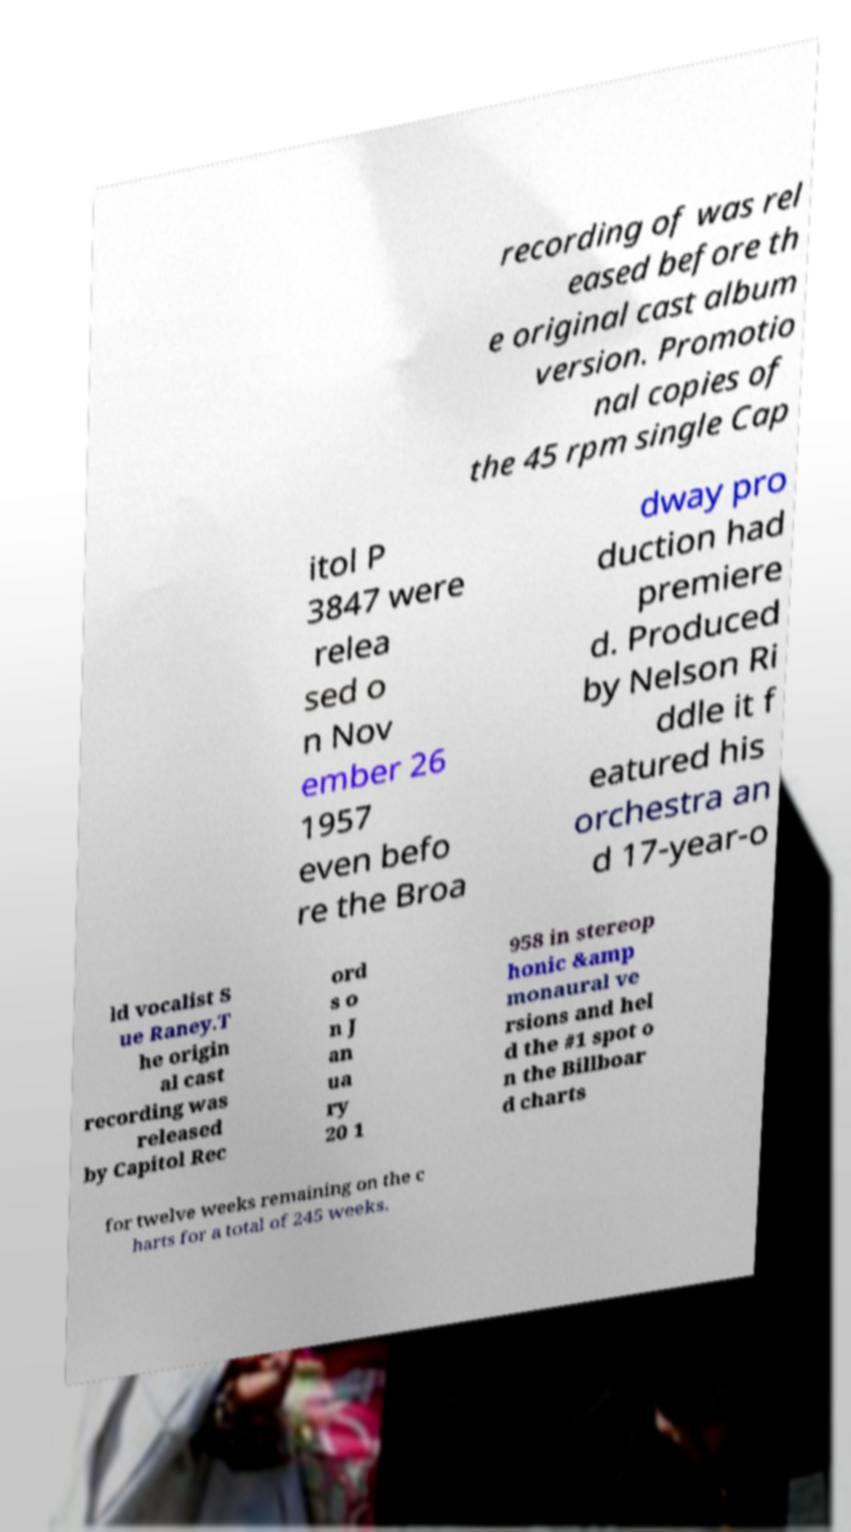There's text embedded in this image that I need extracted. Can you transcribe it verbatim? recording of was rel eased before th e original cast album version. Promotio nal copies of the 45 rpm single Cap itol P 3847 were relea sed o n Nov ember 26 1957 even befo re the Broa dway pro duction had premiere d. Produced by Nelson Ri ddle it f eatured his orchestra an d 17-year-o ld vocalist S ue Raney.T he origin al cast recording was released by Capitol Rec ord s o n J an ua ry 20 1 958 in stereop honic &amp monaural ve rsions and hel d the #1 spot o n the Billboar d charts for twelve weeks remaining on the c harts for a total of 245 weeks. 